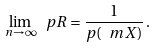<formula> <loc_0><loc_0><loc_500><loc_500>\lim _ { n \rightarrow \infty } \ p R = \frac { 1 } { p ( \ m X ) } \, .</formula> 